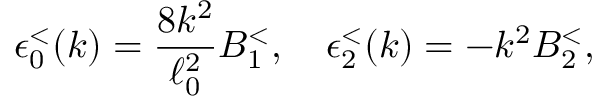<formula> <loc_0><loc_0><loc_500><loc_500>\epsilon _ { 0 } ^ { < } ( k ) = { \frac { 8 k ^ { 2 } } { \ell _ { 0 } ^ { 2 } } } B _ { 1 } ^ { < } , \quad \epsilon _ { 2 } ^ { < } ( k ) = - k ^ { 2 } B _ { 2 } ^ { < } ,</formula> 